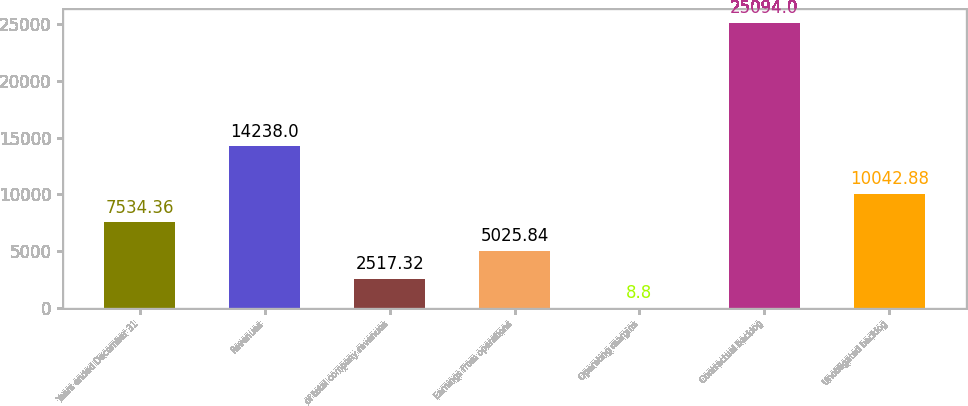<chart> <loc_0><loc_0><loc_500><loc_500><bar_chart><fcel>Years ended December 31<fcel>Revenues<fcel>of total company revenues<fcel>Earnings from operations<fcel>Operating margins<fcel>Contractual backlog<fcel>Unobligated backlog<nl><fcel>7534.36<fcel>14238<fcel>2517.32<fcel>5025.84<fcel>8.8<fcel>25094<fcel>10042.9<nl></chart> 